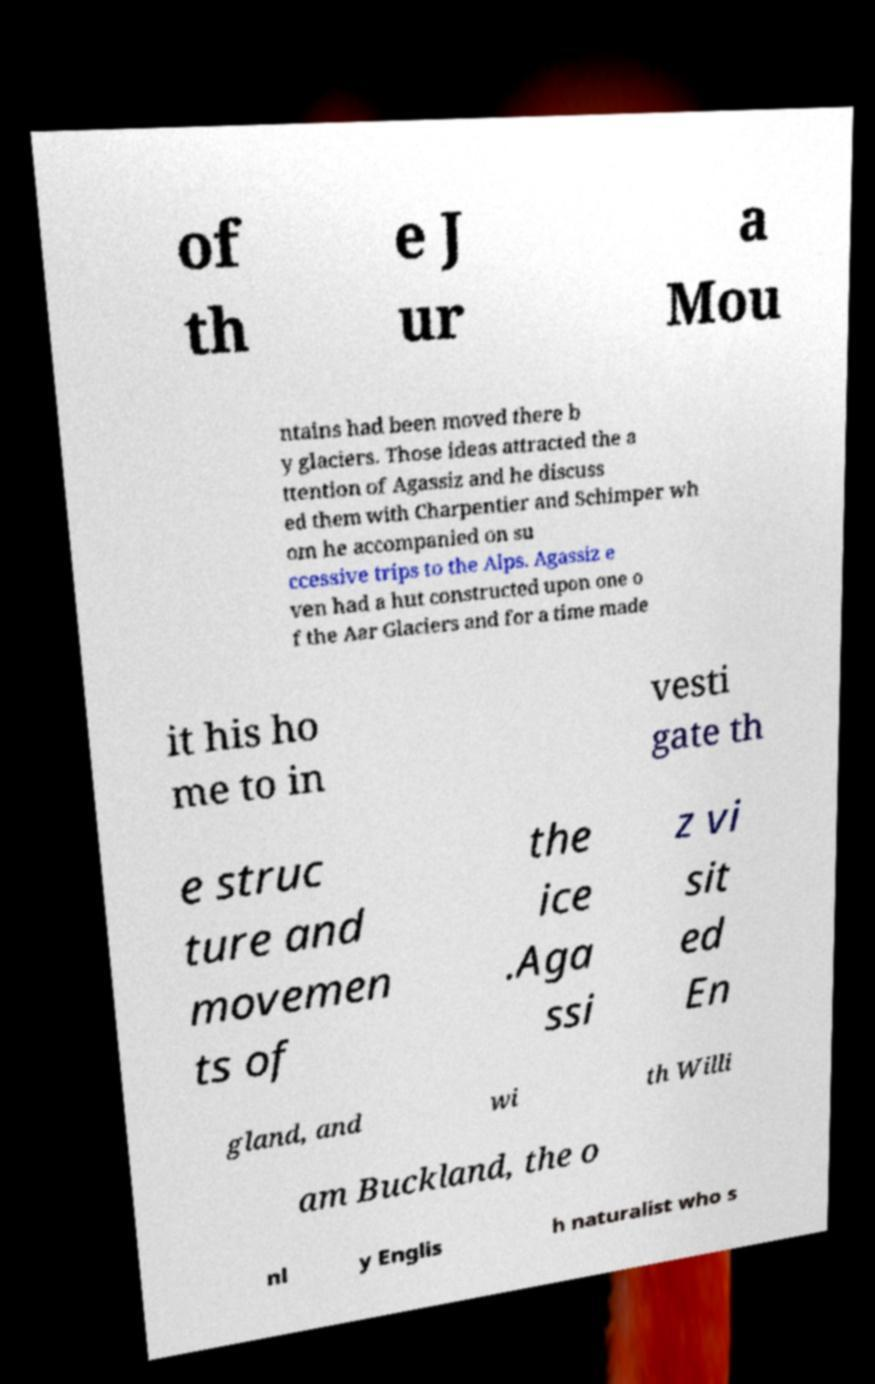Please read and relay the text visible in this image. What does it say? of th e J ur a Mou ntains had been moved there b y glaciers. Those ideas attracted the a ttention of Agassiz and he discuss ed them with Charpentier and Schimper wh om he accompanied on su ccessive trips to the Alps. Agassiz e ven had a hut constructed upon one o f the Aar Glaciers and for a time made it his ho me to in vesti gate th e struc ture and movemen ts of the ice .Aga ssi z vi sit ed En gland, and wi th Willi am Buckland, the o nl y Englis h naturalist who s 